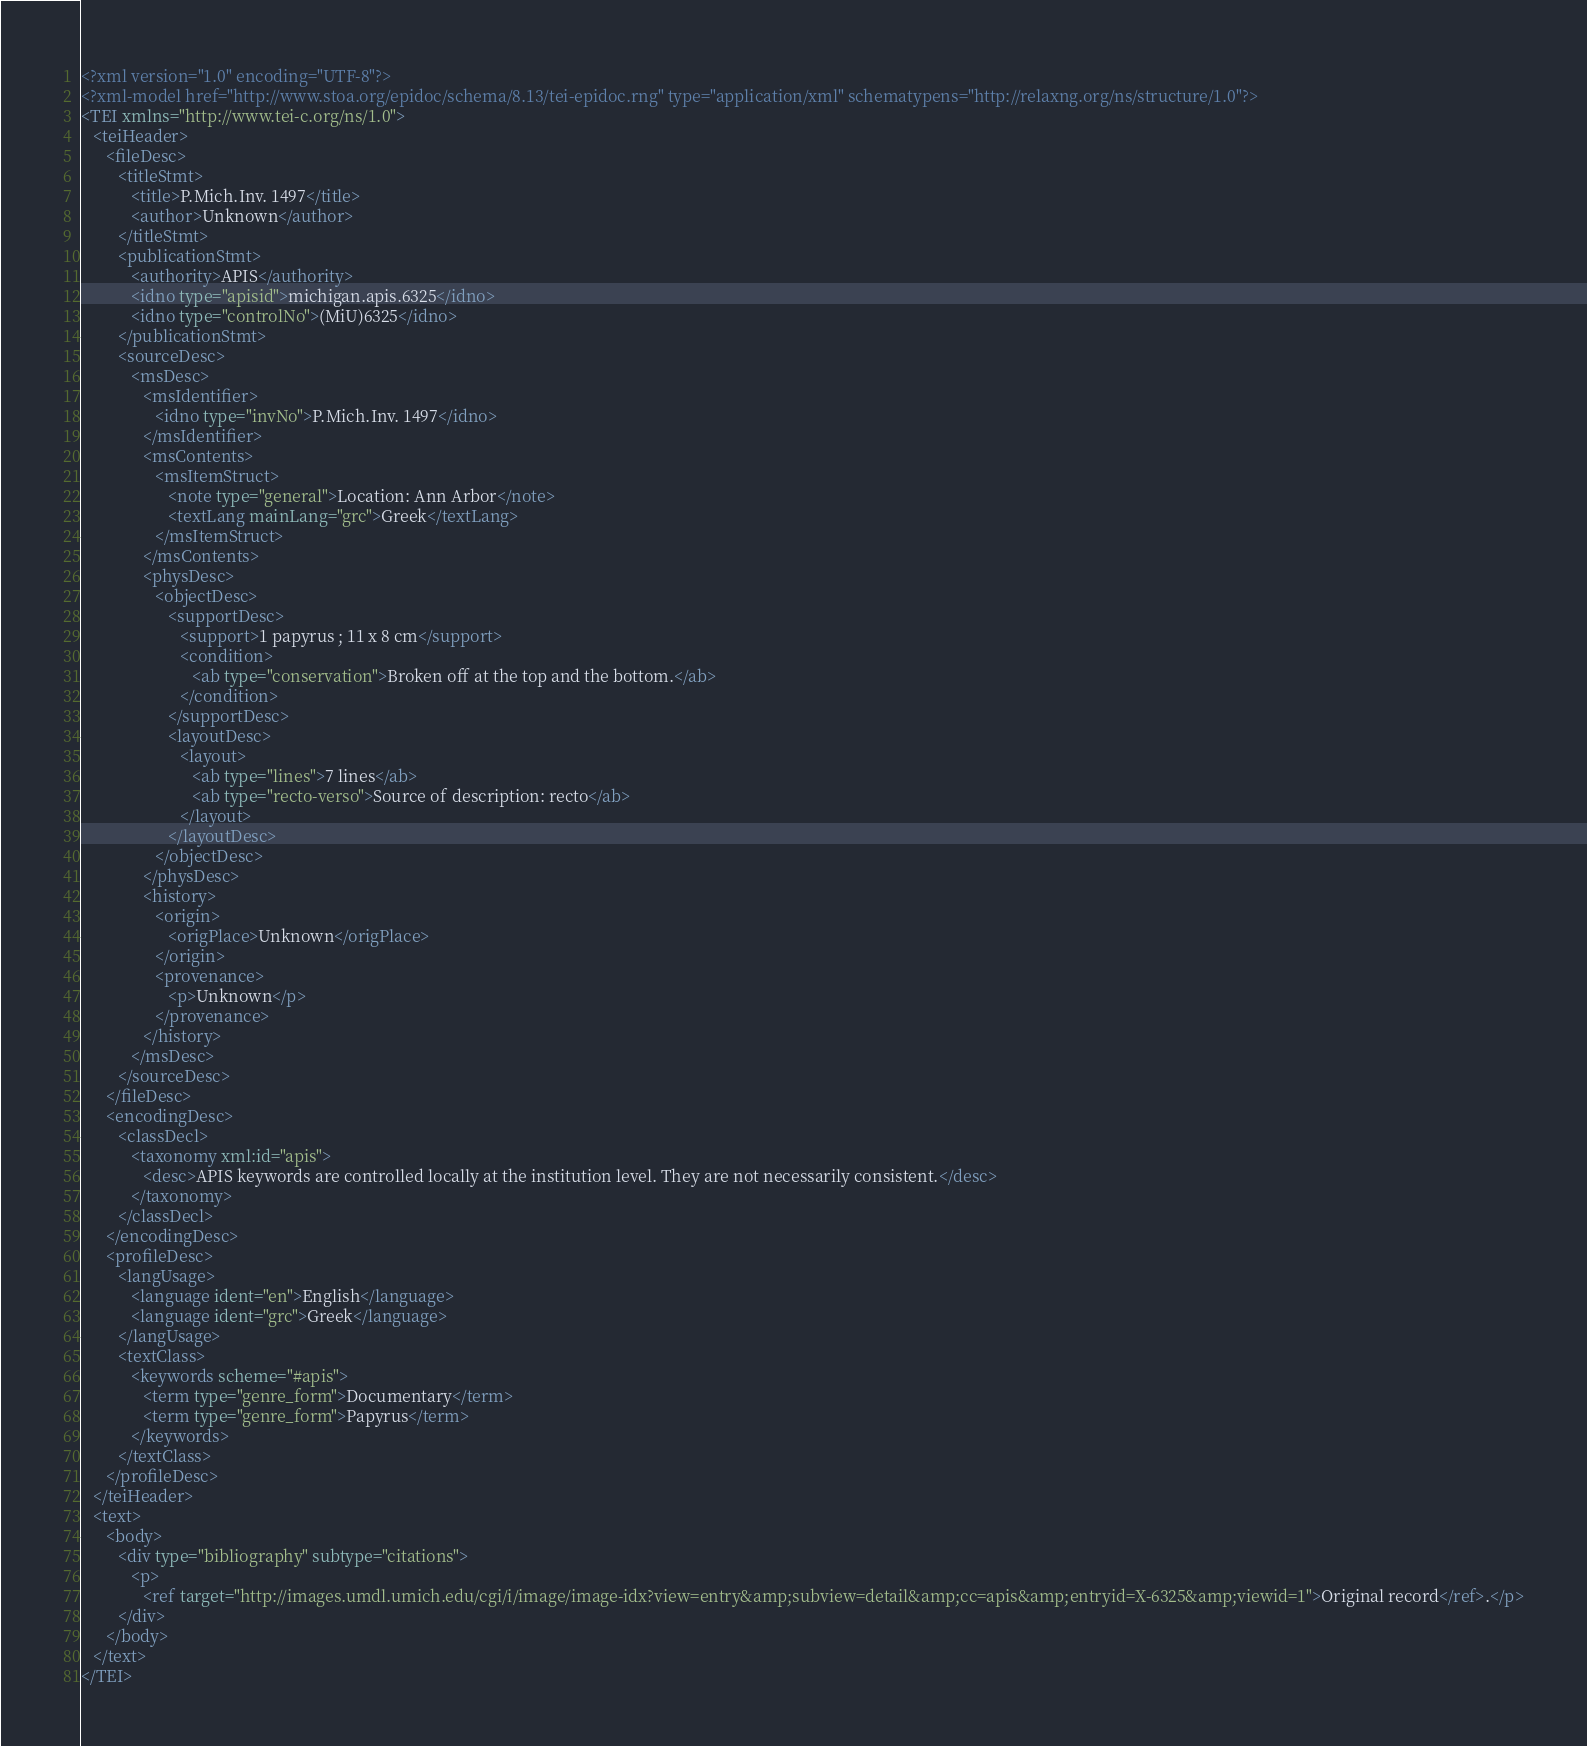<code> <loc_0><loc_0><loc_500><loc_500><_XML_><?xml version="1.0" encoding="UTF-8"?>
<?xml-model href="http://www.stoa.org/epidoc/schema/8.13/tei-epidoc.rng" type="application/xml" schematypens="http://relaxng.org/ns/structure/1.0"?>
<TEI xmlns="http://www.tei-c.org/ns/1.0">
   <teiHeader>
      <fileDesc>
         <titleStmt>
            <title>P.Mich.Inv. 1497</title>
            <author>Unknown</author>
         </titleStmt>
         <publicationStmt>
            <authority>APIS</authority>
            <idno type="apisid">michigan.apis.6325</idno>
            <idno type="controlNo">(MiU)6325</idno>
         </publicationStmt>
         <sourceDesc>
            <msDesc>
               <msIdentifier>
                  <idno type="invNo">P.Mich.Inv. 1497</idno>
               </msIdentifier>
               <msContents>
                  <msItemStruct>
                     <note type="general">Location: Ann Arbor</note>
                     <textLang mainLang="grc">Greek</textLang>
                  </msItemStruct>
               </msContents>
               <physDesc>
                  <objectDesc>
                     <supportDesc>
                        <support>1 papyrus ; 11 x 8 cm</support>
                        <condition>
                           <ab type="conservation">Broken off at the top and the bottom.</ab>
                        </condition>
                     </supportDesc>
                     <layoutDesc>
                        <layout>
                           <ab type="lines">7 lines</ab>
                           <ab type="recto-verso">Source of description: recto</ab>
                        </layout>
                     </layoutDesc>
                  </objectDesc>
               </physDesc>
               <history>
                  <origin>
                     <origPlace>Unknown</origPlace>
                  </origin>
                  <provenance>
                     <p>Unknown</p>
                  </provenance>
               </history>
            </msDesc>
         </sourceDesc>
      </fileDesc>
      <encodingDesc>
         <classDecl>
            <taxonomy xml:id="apis">
               <desc>APIS keywords are controlled locally at the institution level. They are not necessarily consistent.</desc>
            </taxonomy>
         </classDecl>
      </encodingDesc>
      <profileDesc>
         <langUsage>
            <language ident="en">English</language>
            <language ident="grc">Greek</language>
         </langUsage>
         <textClass>
            <keywords scheme="#apis">
               <term type="genre_form">Documentary</term>
               <term type="genre_form">Papyrus</term>
            </keywords>
         </textClass>
      </profileDesc>
   </teiHeader>
   <text>
      <body>
         <div type="bibliography" subtype="citations">
            <p>
               <ref target="http://images.umdl.umich.edu/cgi/i/image/image-idx?view=entry&amp;subview=detail&amp;cc=apis&amp;entryid=X-6325&amp;viewid=1">Original record</ref>.</p>
         </div>
      </body>
   </text>
</TEI>
</code> 